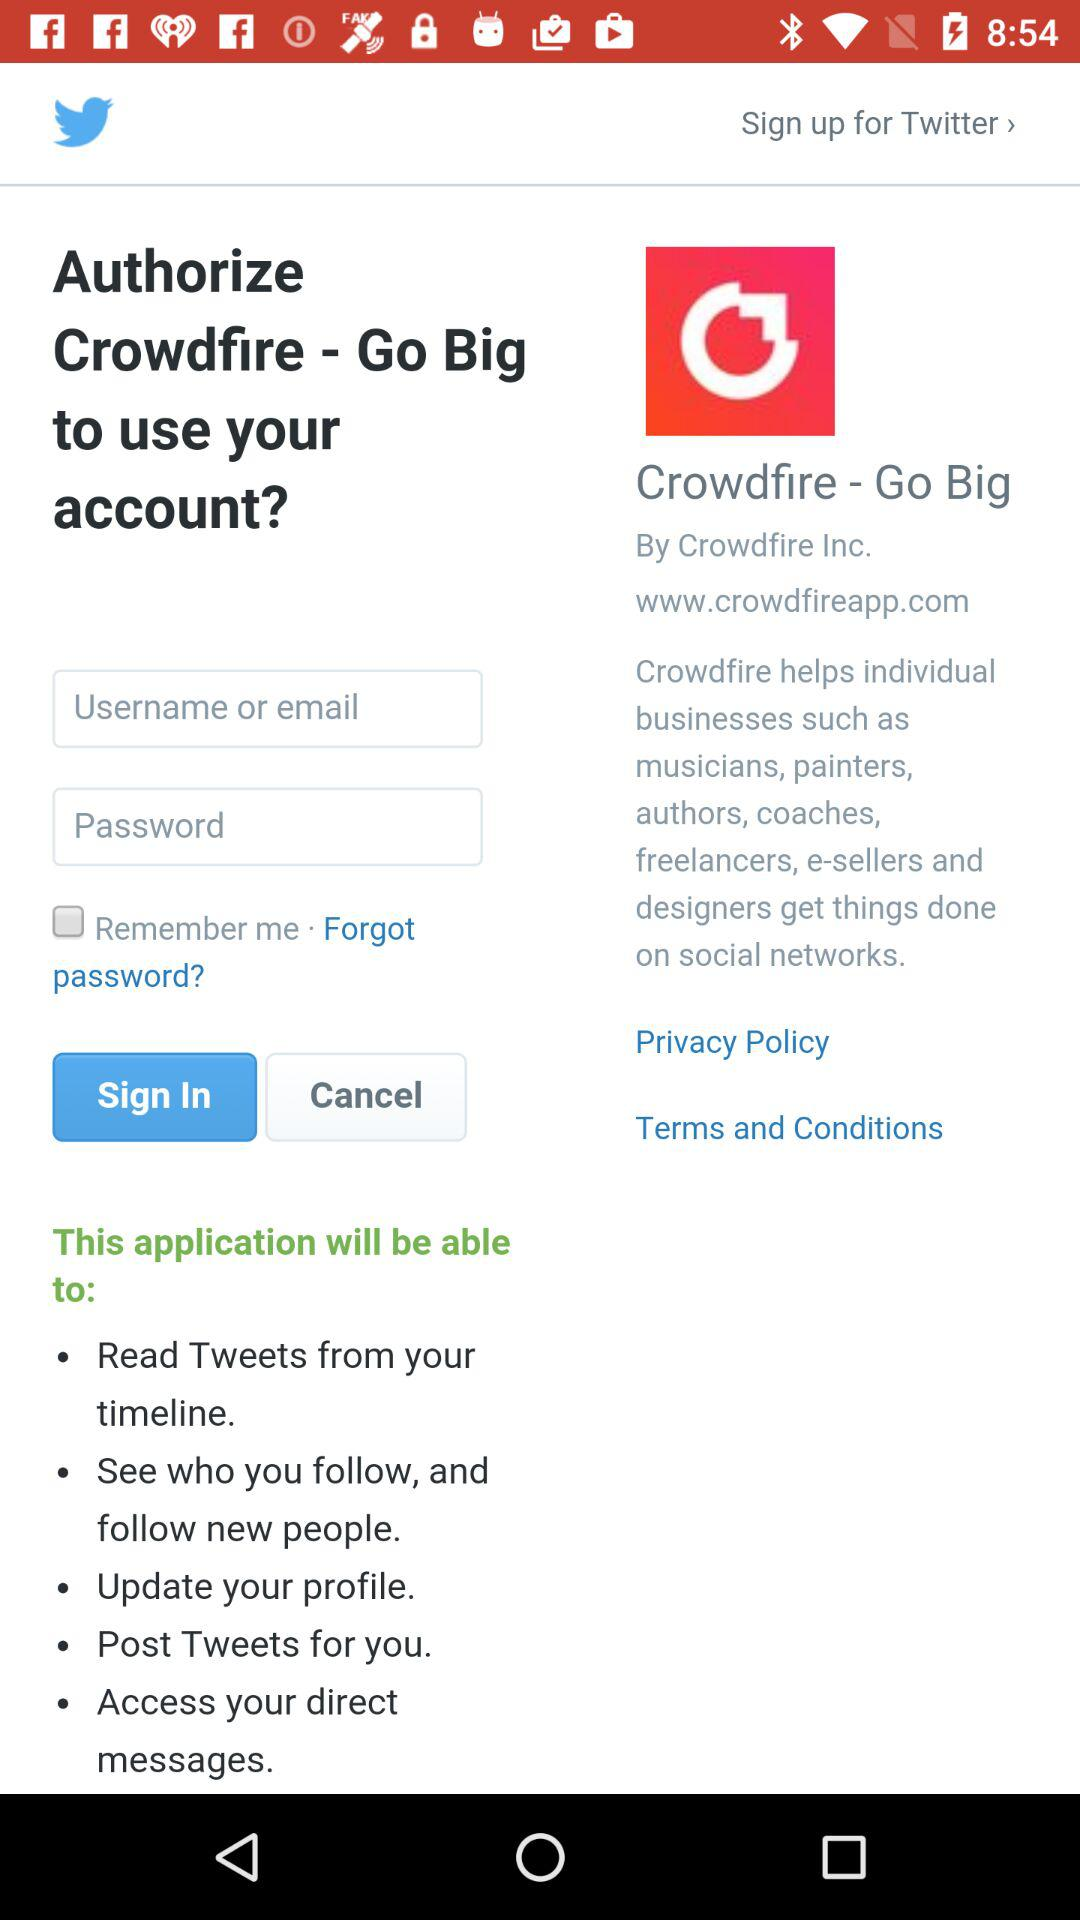By whom is "Crowdfire" published? "Crowdfire" is published by "Crowdfire Inc.". 